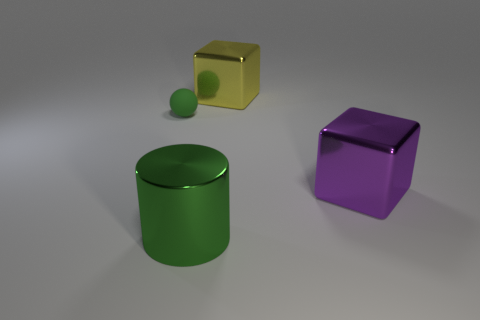Does the large green cylinder have the same material as the big purple block? Yes, both the large green cylinder and the big purple block appear to have a smooth, shiny surface indicating they might be made of similar materials like plastic or polished metal. 